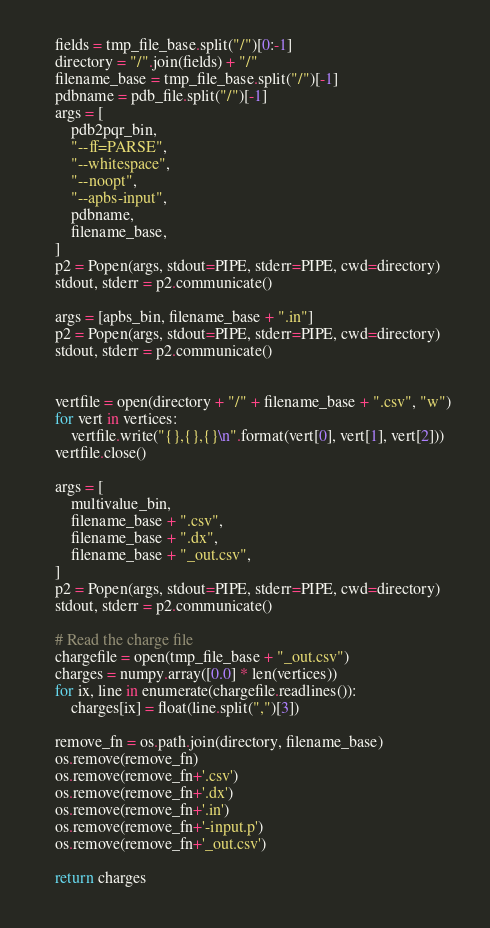Convert code to text. <code><loc_0><loc_0><loc_500><loc_500><_Python_>    fields = tmp_file_base.split("/")[0:-1]
    directory = "/".join(fields) + "/"
    filename_base = tmp_file_base.split("/")[-1]
    pdbname = pdb_file.split("/")[-1]
    args = [
        pdb2pqr_bin,
        "--ff=PARSE",
        "--whitespace",
        "--noopt",
        "--apbs-input",
        pdbname,
        filename_base,
    ]
    p2 = Popen(args, stdout=PIPE, stderr=PIPE, cwd=directory)
    stdout, stderr = p2.communicate()

    args = [apbs_bin, filename_base + ".in"]
    p2 = Popen(args, stdout=PIPE, stderr=PIPE, cwd=directory)
    stdout, stderr = p2.communicate()


    vertfile = open(directory + "/" + filename_base + ".csv", "w")
    for vert in vertices:
        vertfile.write("{},{},{}\n".format(vert[0], vert[1], vert[2]))
    vertfile.close()

    args = [
        multivalue_bin,
        filename_base + ".csv",
        filename_base + ".dx",
        filename_base + "_out.csv",
    ]
    p2 = Popen(args, stdout=PIPE, stderr=PIPE, cwd=directory)
    stdout, stderr = p2.communicate()

    # Read the charge file
    chargefile = open(tmp_file_base + "_out.csv")
    charges = numpy.array([0.0] * len(vertices))
    for ix, line in enumerate(chargefile.readlines()):
        charges[ix] = float(line.split(",")[3])

    remove_fn = os.path.join(directory, filename_base)
    os.remove(remove_fn)
    os.remove(remove_fn+'.csv')
    os.remove(remove_fn+'.dx')
    os.remove(remove_fn+'.in')
    os.remove(remove_fn+'-input.p')
    os.remove(remove_fn+'_out.csv')

    return charges
</code> 